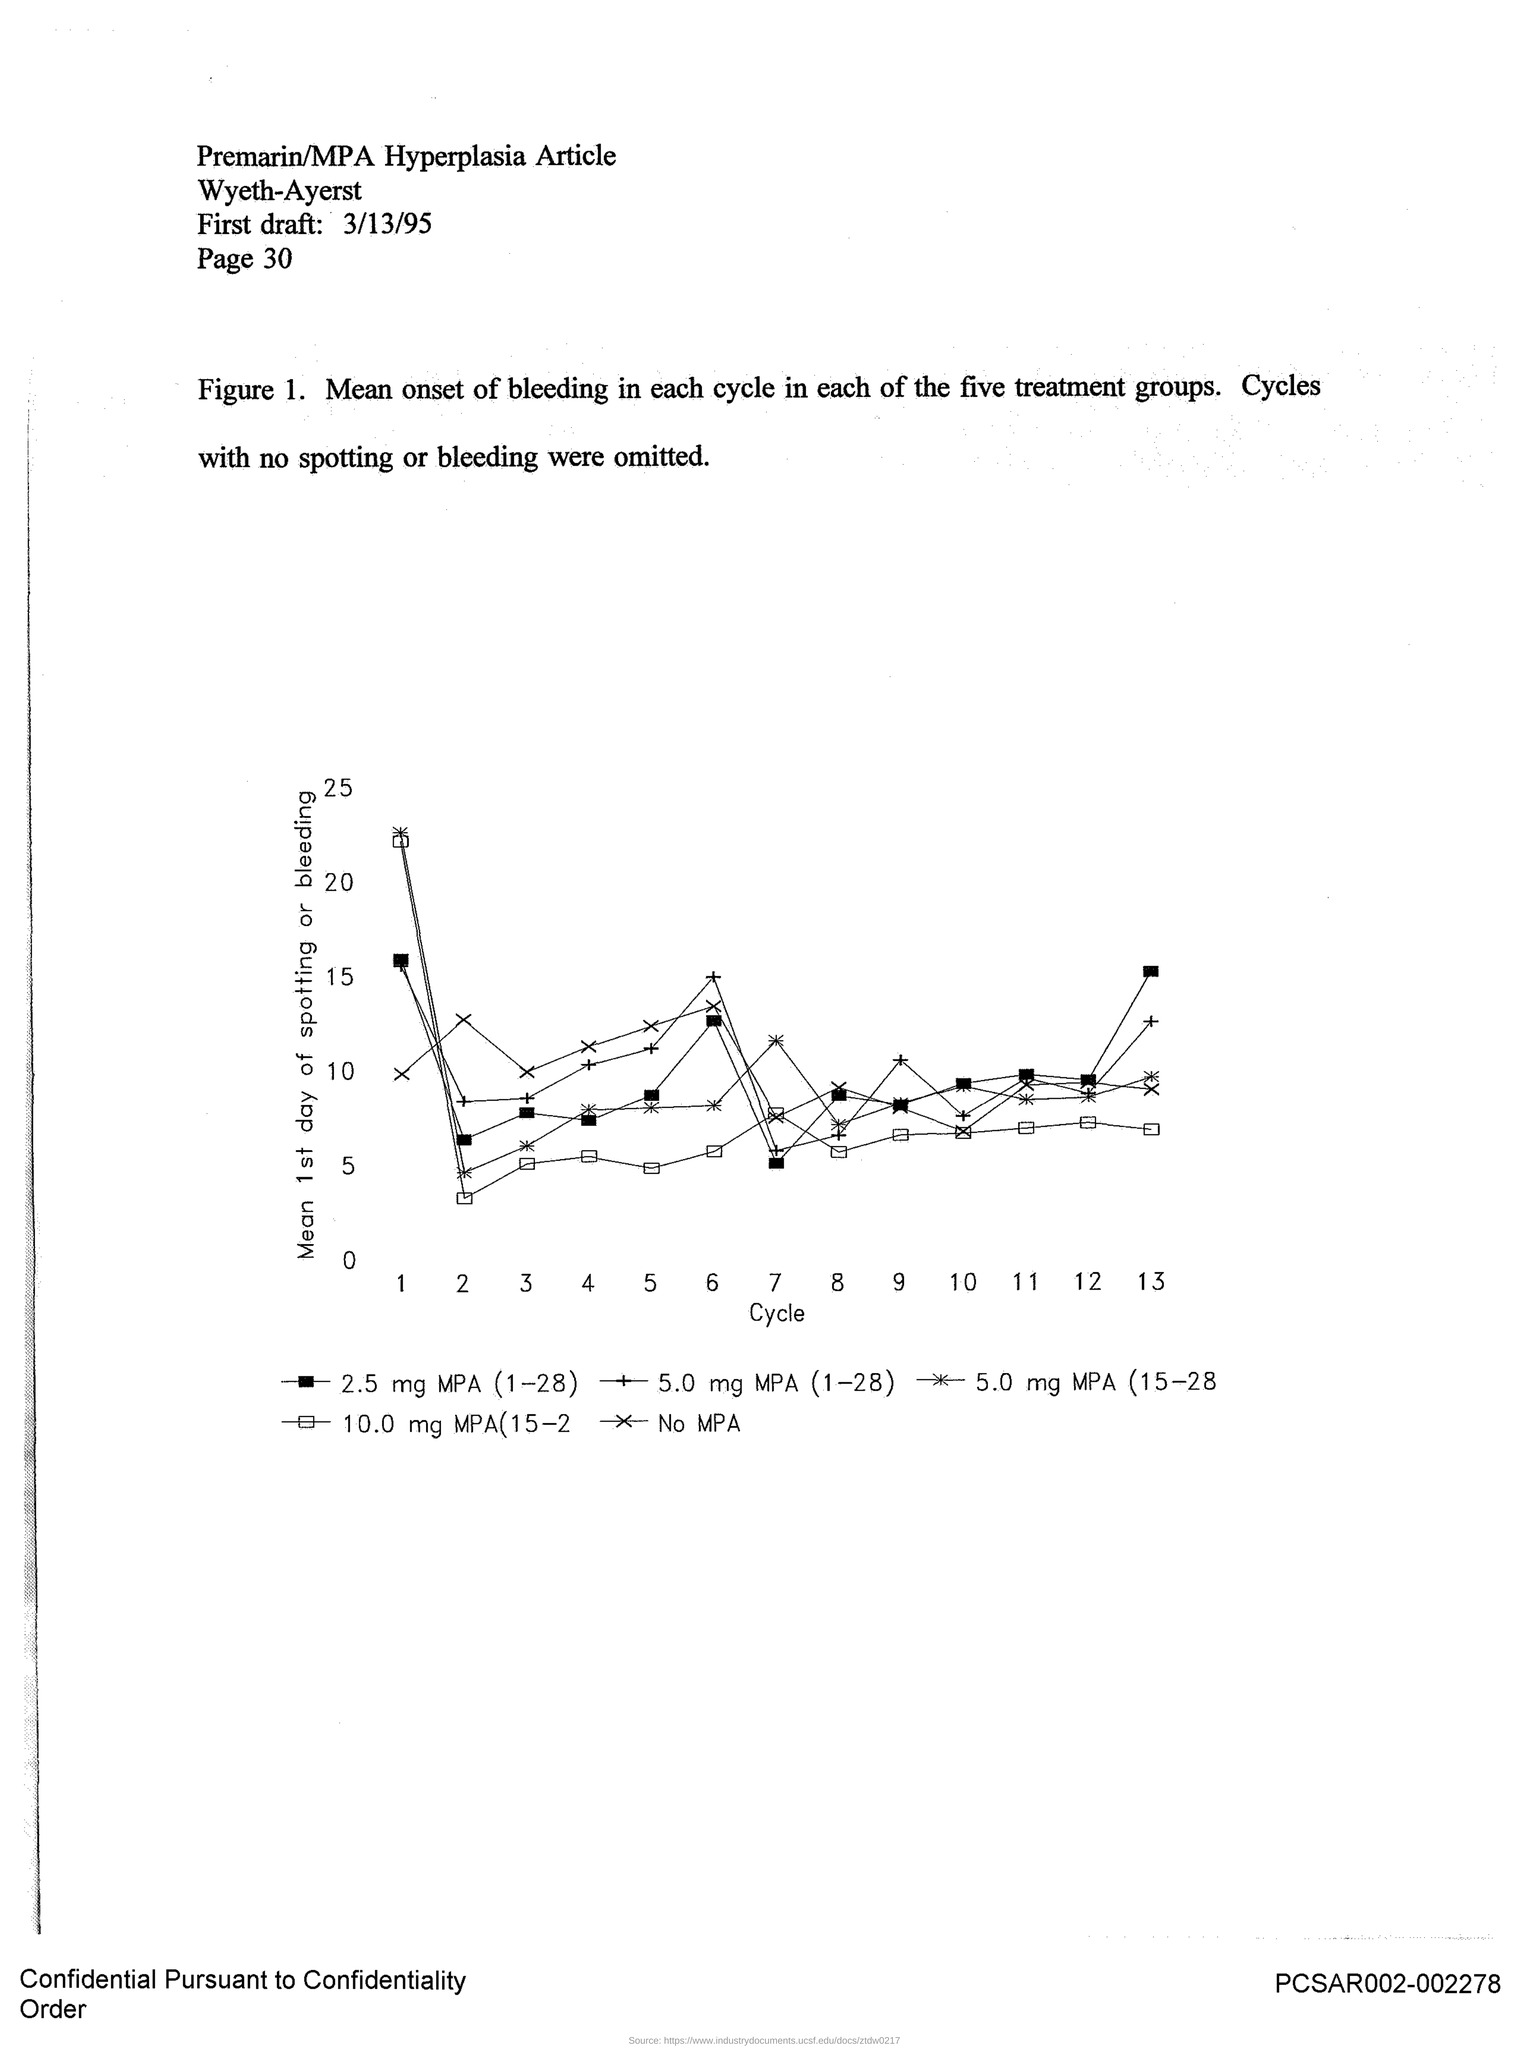List a handful of essential elements in this visual. The mean of the first day of spotting or bleeding is plotted on the y-axis. The x-axis displays the cycles that are plotted. 